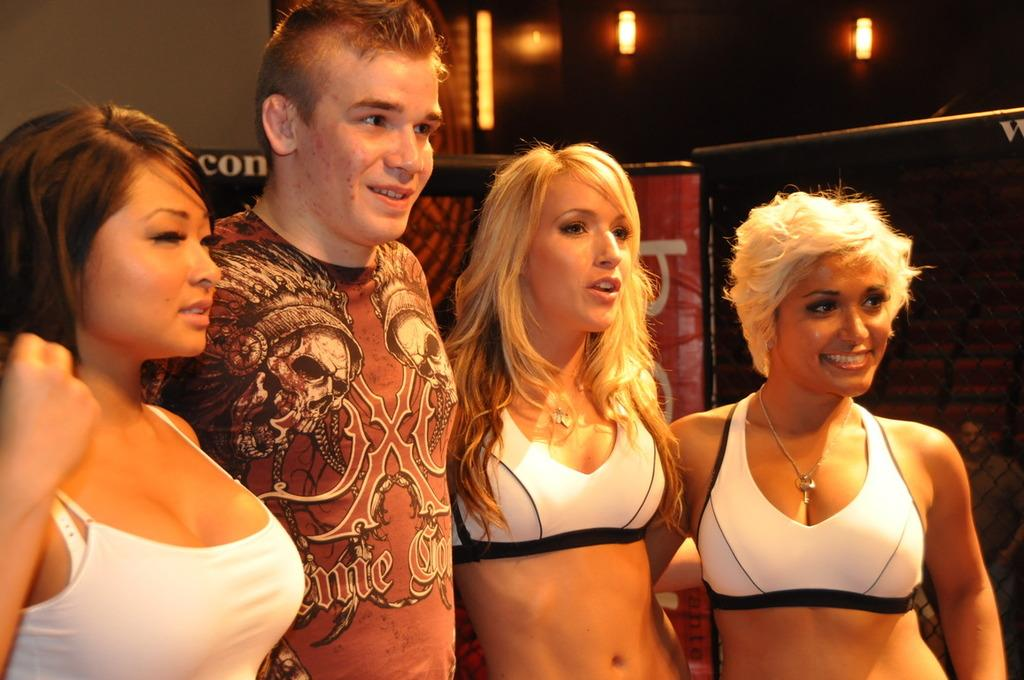How many people are in the image? There are three women in the image. What are the people in the image wearing? There is a person wearing a T-shirt in the image. What are the people in the image doing? The people are standing and smiling. What can be seen on the wall in the background? There are boards and lights on the wall in the background. What type of cherry is being used as a hair accessory by one of the women in the image? There is no cherry or hair accessory present in the image. How many cushions are visible on the floor in the image? There are no cushions visible on the floor in the image. 